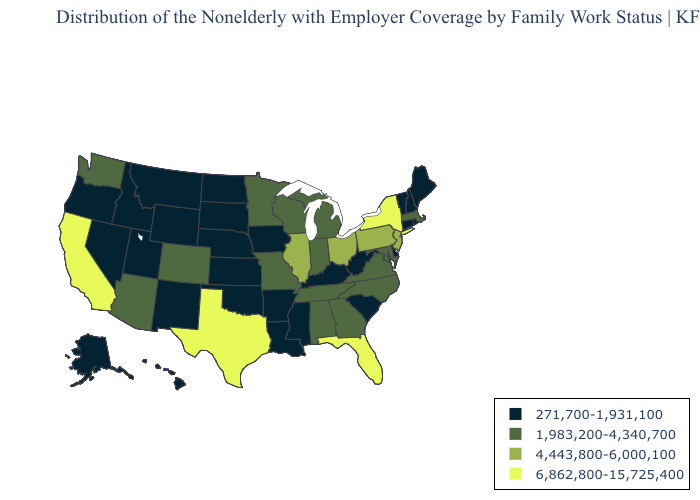What is the value of Kentucky?
Be succinct. 271,700-1,931,100. Name the states that have a value in the range 271,700-1,931,100?
Short answer required. Alaska, Arkansas, Connecticut, Delaware, Hawaii, Idaho, Iowa, Kansas, Kentucky, Louisiana, Maine, Mississippi, Montana, Nebraska, Nevada, New Hampshire, New Mexico, North Dakota, Oklahoma, Oregon, Rhode Island, South Carolina, South Dakota, Utah, Vermont, West Virginia, Wyoming. What is the highest value in the Northeast ?
Be succinct. 6,862,800-15,725,400. Name the states that have a value in the range 1,983,200-4,340,700?
Be succinct. Alabama, Arizona, Colorado, Georgia, Indiana, Maryland, Massachusetts, Michigan, Minnesota, Missouri, North Carolina, Tennessee, Virginia, Washington, Wisconsin. How many symbols are there in the legend?
Quick response, please. 4. Which states have the lowest value in the South?
Concise answer only. Arkansas, Delaware, Kentucky, Louisiana, Mississippi, Oklahoma, South Carolina, West Virginia. Which states have the lowest value in the Northeast?
Give a very brief answer. Connecticut, Maine, New Hampshire, Rhode Island, Vermont. Among the states that border Texas , which have the lowest value?
Write a very short answer. Arkansas, Louisiana, New Mexico, Oklahoma. What is the value of Connecticut?
Short answer required. 271,700-1,931,100. Does Illinois have the same value as Oregon?
Short answer required. No. Which states have the lowest value in the USA?
Keep it brief. Alaska, Arkansas, Connecticut, Delaware, Hawaii, Idaho, Iowa, Kansas, Kentucky, Louisiana, Maine, Mississippi, Montana, Nebraska, Nevada, New Hampshire, New Mexico, North Dakota, Oklahoma, Oregon, Rhode Island, South Carolina, South Dakota, Utah, Vermont, West Virginia, Wyoming. Does Kansas have the lowest value in the MidWest?
Concise answer only. Yes. What is the value of South Carolina?
Keep it brief. 271,700-1,931,100. What is the value of California?
Concise answer only. 6,862,800-15,725,400. 